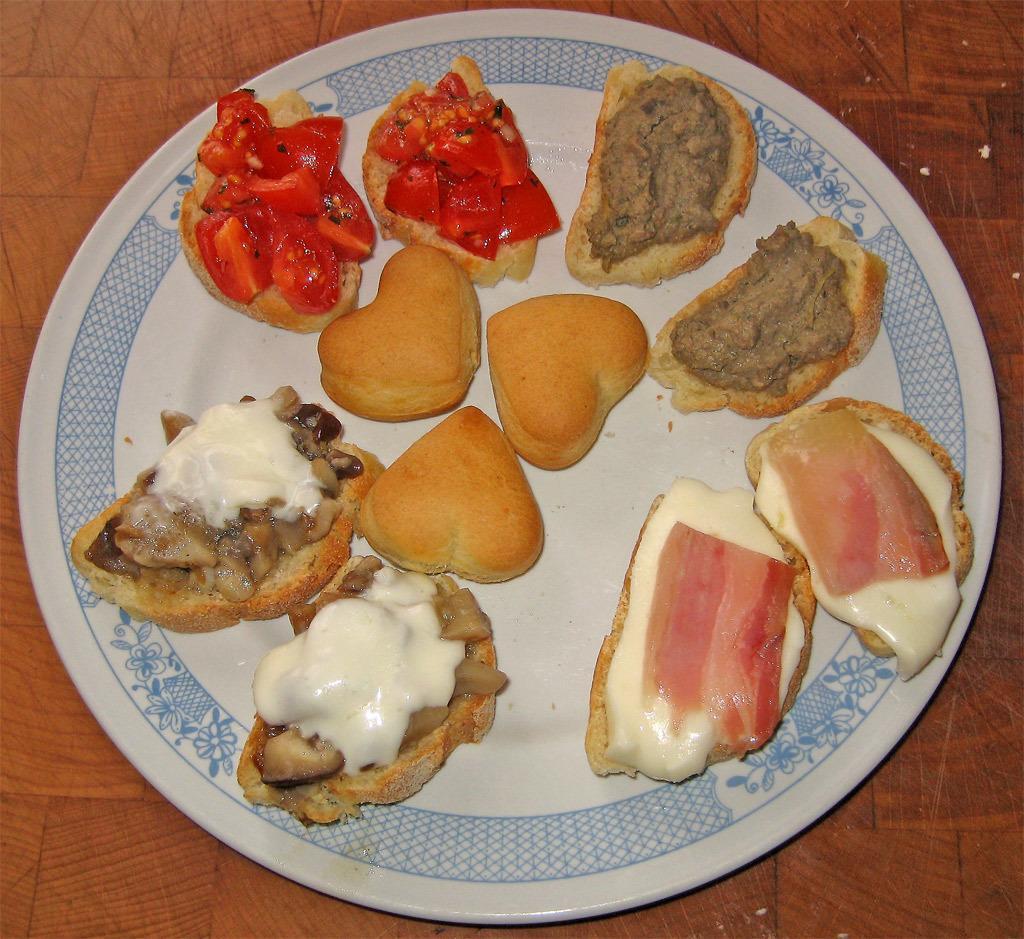Can you describe this image briefly? This picture shows food in the plate and we see cheese and meat and veggies on the bread and we see plate on the table. 